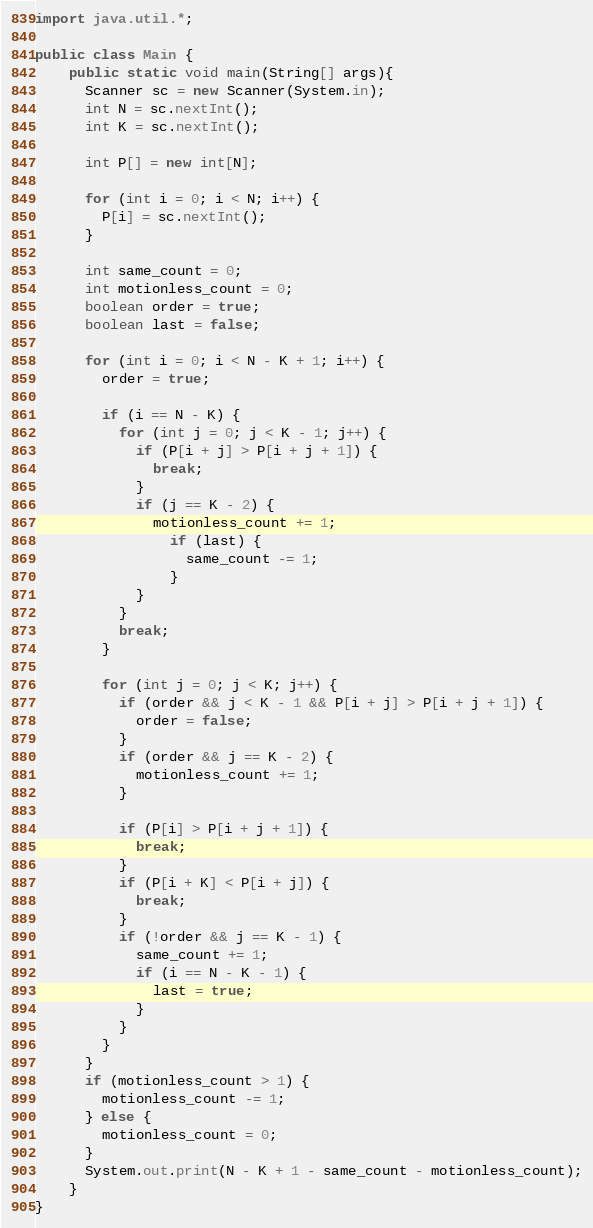<code> <loc_0><loc_0><loc_500><loc_500><_Java_>import java.util.*;
 
public class Main {
    public static void main(String[] args){
      Scanner sc = new Scanner(System.in);
      int N = sc.nextInt();
      int K = sc.nextInt();
      
      int P[] = new int[N];
        
      for (int i = 0; i < N; i++) {
        P[i] = sc.nextInt();
      }
      
      int same_count = 0;
      int motionless_count = 0;
      boolean order = true;
      boolean last = false;
      
      for (int i = 0; i < N - K + 1; i++) {
        order = true;
        
        if (i == N - K) {
          for (int j = 0; j < K - 1; j++) {
            if (P[i + j] > P[i + j + 1]) {
              break;
            }
            if (j == K - 2) {           
              motionless_count += 1;
                if (last) {
                  same_count -= 1;
                }
            }
          }
          break;
        }
        
        for (int j = 0; j < K; j++) {
          if (order && j < K - 1 && P[i + j] > P[i + j + 1]) {
            order = false;
          }
          if (order && j == K - 2) {
            motionless_count += 1;
          }
          
          if (P[i] > P[i + j + 1]) {
            break;
          }
          if (P[i + K] < P[i + j]) {
            break;
          }
          if (!order && j == K - 1) {
            same_count += 1;
            if (i == N - K - 1) {
              last = true;
            }
          }       
        }
      }
      if (motionless_count > 1) {
        motionless_count -= 1;
      } else {
        motionless_count = 0;
      }
      System.out.print(N - K + 1 - same_count - motionless_count);
    }
}</code> 